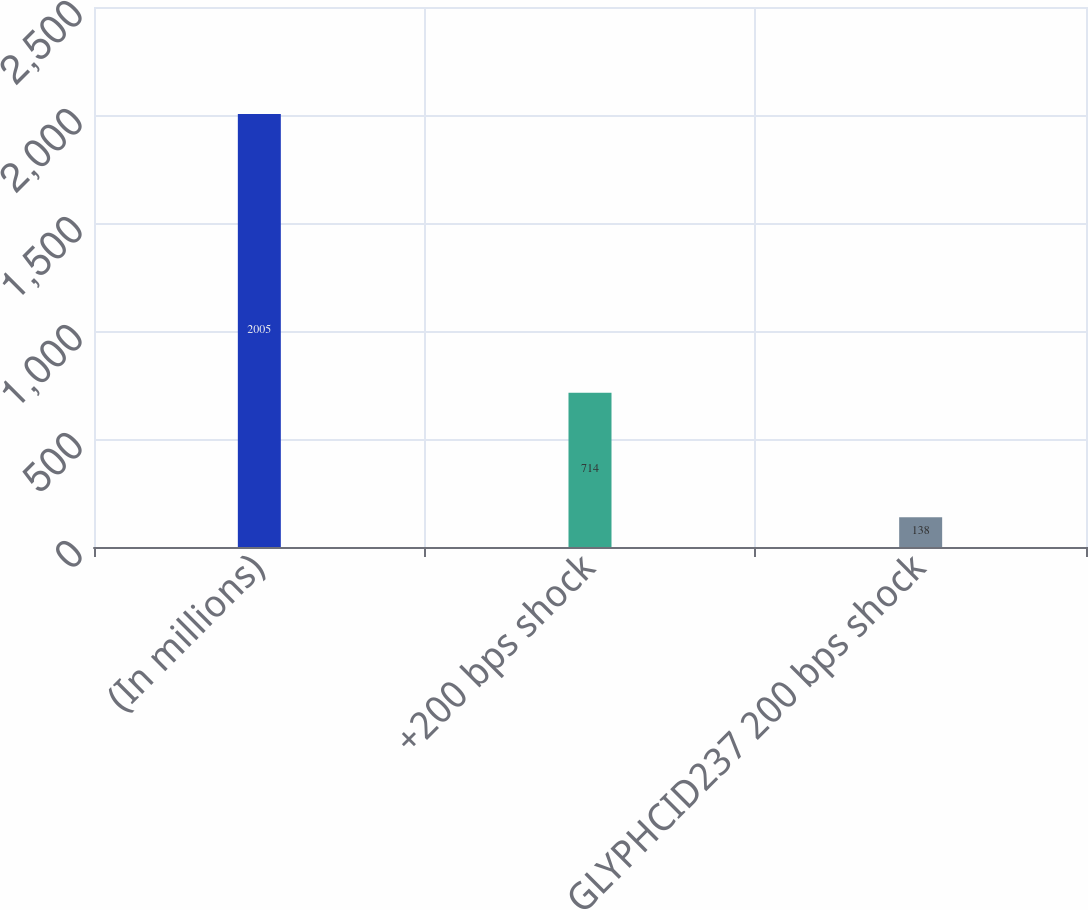Convert chart. <chart><loc_0><loc_0><loc_500><loc_500><bar_chart><fcel>(In millions)<fcel>+200 bps shock<fcel>GLYPHCID237 200 bps shock<nl><fcel>2005<fcel>714<fcel>138<nl></chart> 